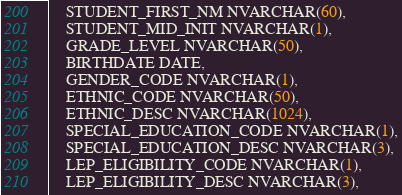<code> <loc_0><loc_0><loc_500><loc_500><_SQL_>    STUDENT_FIRST_NM NVARCHAR(60),
    STUDENT_MID_INIT NVARCHAR(1),
    GRADE_LEVEL NVARCHAR(50),
    BIRTHDATE DATE,
    GENDER_CODE NVARCHAR(1),
    ETHNIC_CODE NVARCHAR(50),
    ETHNIC_DESC NVARCHAR(1024),
    SPECIAL_EDUCATION_CODE NVARCHAR(1),
    SPECIAL_EDUCATION_DESC NVARCHAR(3),
    LEP_ELIGIBILITY_CODE NVARCHAR(1),
    LEP_ELIGIBILITY_DESC NVARCHAR(3),</code> 